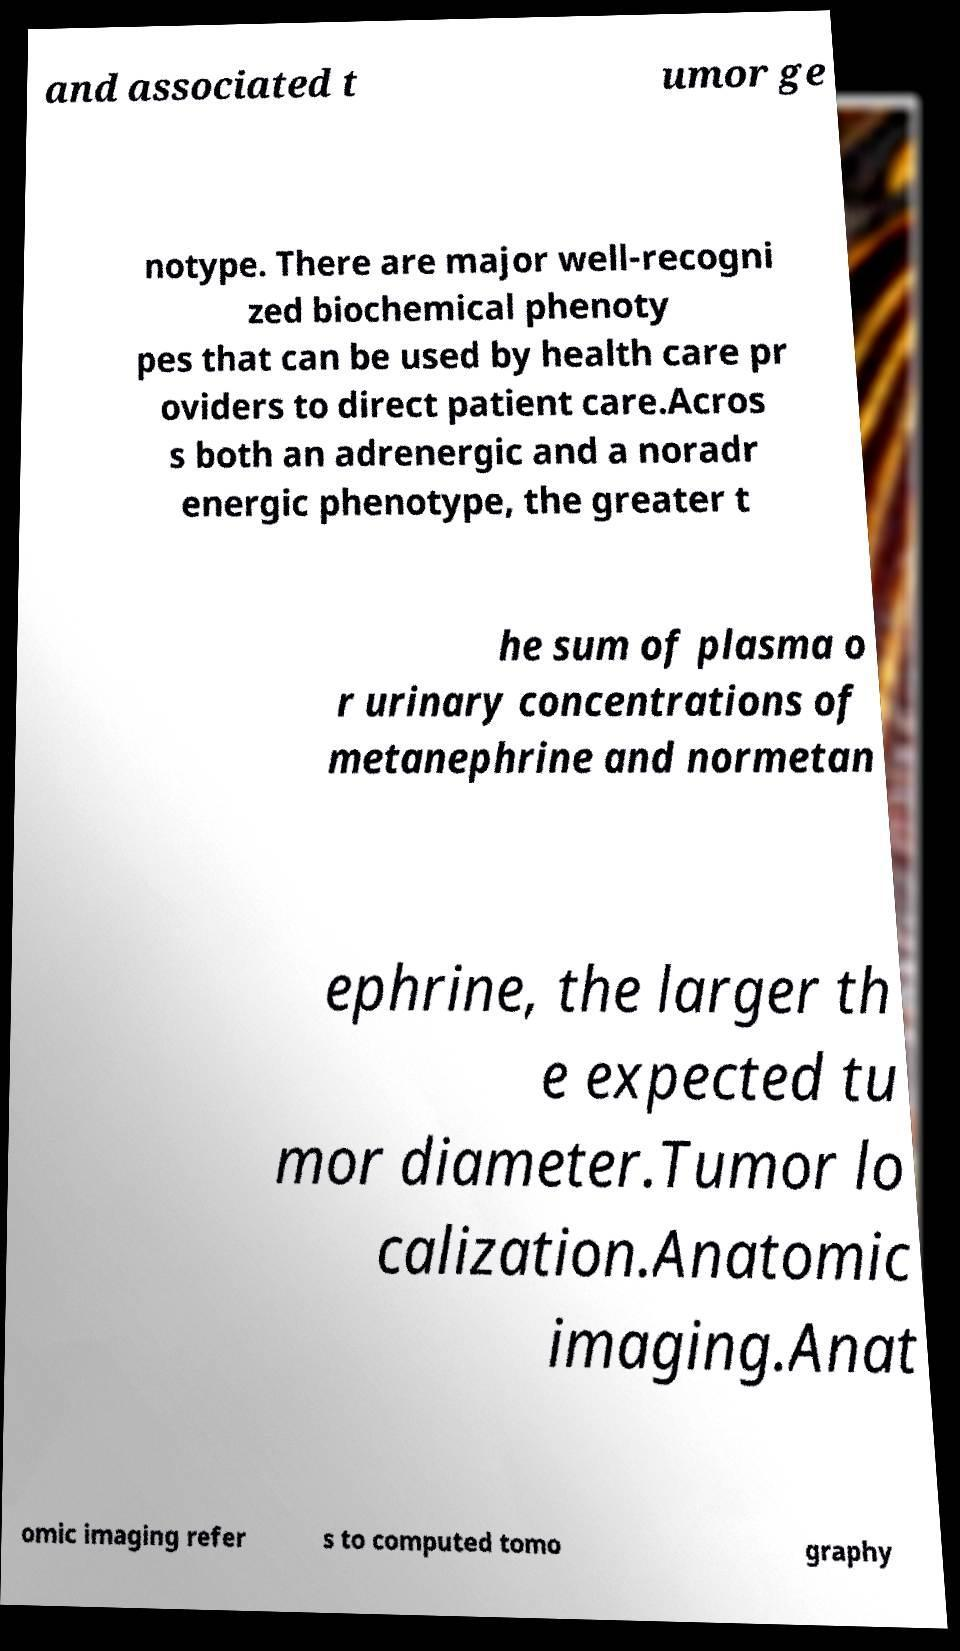Please read and relay the text visible in this image. What does it say? and associated t umor ge notype. There are major well-recogni zed biochemical phenoty pes that can be used by health care pr oviders to direct patient care.Acros s both an adrenergic and a noradr energic phenotype, the greater t he sum of plasma o r urinary concentrations of metanephrine and normetan ephrine, the larger th e expected tu mor diameter.Tumor lo calization.Anatomic imaging.Anat omic imaging refer s to computed tomo graphy 